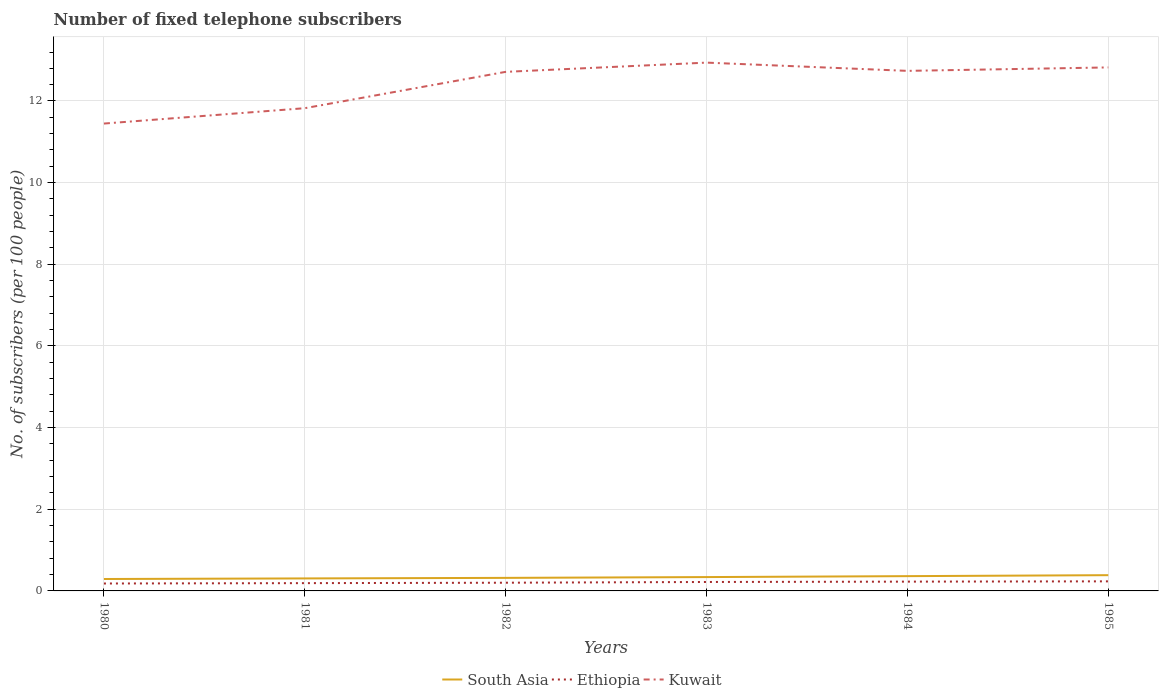Does the line corresponding to South Asia intersect with the line corresponding to Kuwait?
Keep it short and to the point. No. Across all years, what is the maximum number of fixed telephone subscribers in South Asia?
Your answer should be compact. 0.29. What is the total number of fixed telephone subscribers in Ethiopia in the graph?
Give a very brief answer. -0.01. What is the difference between the highest and the second highest number of fixed telephone subscribers in South Asia?
Make the answer very short. 0.09. What is the difference between the highest and the lowest number of fixed telephone subscribers in Kuwait?
Give a very brief answer. 4. How many lines are there?
Provide a succinct answer. 3. How many years are there in the graph?
Offer a terse response. 6. Are the values on the major ticks of Y-axis written in scientific E-notation?
Make the answer very short. No. Does the graph contain grids?
Ensure brevity in your answer.  Yes. Where does the legend appear in the graph?
Keep it short and to the point. Bottom center. How are the legend labels stacked?
Offer a very short reply. Horizontal. What is the title of the graph?
Your answer should be very brief. Number of fixed telephone subscribers. Does "Norway" appear as one of the legend labels in the graph?
Make the answer very short. No. What is the label or title of the X-axis?
Your response must be concise. Years. What is the label or title of the Y-axis?
Your answer should be very brief. No. of subscribers (per 100 people). What is the No. of subscribers (per 100 people) of South Asia in 1980?
Ensure brevity in your answer.  0.29. What is the No. of subscribers (per 100 people) of Ethiopia in 1980?
Offer a terse response. 0.18. What is the No. of subscribers (per 100 people) of Kuwait in 1980?
Offer a very short reply. 11.45. What is the No. of subscribers (per 100 people) of South Asia in 1981?
Give a very brief answer. 0.31. What is the No. of subscribers (per 100 people) in Ethiopia in 1981?
Ensure brevity in your answer.  0.19. What is the No. of subscribers (per 100 people) of Kuwait in 1981?
Provide a short and direct response. 11.82. What is the No. of subscribers (per 100 people) of South Asia in 1982?
Offer a terse response. 0.32. What is the No. of subscribers (per 100 people) of Ethiopia in 1982?
Your answer should be very brief. 0.2. What is the No. of subscribers (per 100 people) in Kuwait in 1982?
Offer a terse response. 12.71. What is the No. of subscribers (per 100 people) of South Asia in 1983?
Your answer should be compact. 0.34. What is the No. of subscribers (per 100 people) of Ethiopia in 1983?
Your response must be concise. 0.22. What is the No. of subscribers (per 100 people) in Kuwait in 1983?
Your answer should be compact. 12.94. What is the No. of subscribers (per 100 people) of South Asia in 1984?
Give a very brief answer. 0.36. What is the No. of subscribers (per 100 people) in Ethiopia in 1984?
Provide a succinct answer. 0.23. What is the No. of subscribers (per 100 people) in Kuwait in 1984?
Your answer should be compact. 12.74. What is the No. of subscribers (per 100 people) of South Asia in 1985?
Offer a very short reply. 0.39. What is the No. of subscribers (per 100 people) of Ethiopia in 1985?
Offer a very short reply. 0.23. What is the No. of subscribers (per 100 people) of Kuwait in 1985?
Make the answer very short. 12.82. Across all years, what is the maximum No. of subscribers (per 100 people) of South Asia?
Give a very brief answer. 0.39. Across all years, what is the maximum No. of subscribers (per 100 people) in Ethiopia?
Your response must be concise. 0.23. Across all years, what is the maximum No. of subscribers (per 100 people) of Kuwait?
Ensure brevity in your answer.  12.94. Across all years, what is the minimum No. of subscribers (per 100 people) in South Asia?
Your answer should be very brief. 0.29. Across all years, what is the minimum No. of subscribers (per 100 people) in Ethiopia?
Offer a terse response. 0.18. Across all years, what is the minimum No. of subscribers (per 100 people) of Kuwait?
Provide a short and direct response. 11.45. What is the total No. of subscribers (per 100 people) of South Asia in the graph?
Provide a succinct answer. 2. What is the total No. of subscribers (per 100 people) in Ethiopia in the graph?
Your response must be concise. 1.25. What is the total No. of subscribers (per 100 people) in Kuwait in the graph?
Your response must be concise. 74.49. What is the difference between the No. of subscribers (per 100 people) of South Asia in 1980 and that in 1981?
Provide a succinct answer. -0.01. What is the difference between the No. of subscribers (per 100 people) in Ethiopia in 1980 and that in 1981?
Offer a terse response. -0.01. What is the difference between the No. of subscribers (per 100 people) in Kuwait in 1980 and that in 1981?
Make the answer very short. -0.38. What is the difference between the No. of subscribers (per 100 people) of South Asia in 1980 and that in 1982?
Offer a terse response. -0.03. What is the difference between the No. of subscribers (per 100 people) in Ethiopia in 1980 and that in 1982?
Keep it short and to the point. -0.02. What is the difference between the No. of subscribers (per 100 people) in Kuwait in 1980 and that in 1982?
Ensure brevity in your answer.  -1.27. What is the difference between the No. of subscribers (per 100 people) in South Asia in 1980 and that in 1983?
Offer a terse response. -0.05. What is the difference between the No. of subscribers (per 100 people) in Ethiopia in 1980 and that in 1983?
Your response must be concise. -0.04. What is the difference between the No. of subscribers (per 100 people) in Kuwait in 1980 and that in 1983?
Your answer should be compact. -1.49. What is the difference between the No. of subscribers (per 100 people) of South Asia in 1980 and that in 1984?
Make the answer very short. -0.07. What is the difference between the No. of subscribers (per 100 people) in Ethiopia in 1980 and that in 1984?
Your response must be concise. -0.05. What is the difference between the No. of subscribers (per 100 people) of Kuwait in 1980 and that in 1984?
Ensure brevity in your answer.  -1.29. What is the difference between the No. of subscribers (per 100 people) in South Asia in 1980 and that in 1985?
Offer a very short reply. -0.09. What is the difference between the No. of subscribers (per 100 people) in Ethiopia in 1980 and that in 1985?
Offer a terse response. -0.05. What is the difference between the No. of subscribers (per 100 people) in Kuwait in 1980 and that in 1985?
Provide a succinct answer. -1.37. What is the difference between the No. of subscribers (per 100 people) of South Asia in 1981 and that in 1982?
Offer a terse response. -0.01. What is the difference between the No. of subscribers (per 100 people) in Ethiopia in 1981 and that in 1982?
Offer a very short reply. -0.01. What is the difference between the No. of subscribers (per 100 people) in Kuwait in 1981 and that in 1982?
Provide a succinct answer. -0.89. What is the difference between the No. of subscribers (per 100 people) in South Asia in 1981 and that in 1983?
Make the answer very short. -0.03. What is the difference between the No. of subscribers (per 100 people) of Ethiopia in 1981 and that in 1983?
Provide a succinct answer. -0.03. What is the difference between the No. of subscribers (per 100 people) of Kuwait in 1981 and that in 1983?
Make the answer very short. -1.12. What is the difference between the No. of subscribers (per 100 people) in South Asia in 1981 and that in 1984?
Your answer should be compact. -0.06. What is the difference between the No. of subscribers (per 100 people) of Ethiopia in 1981 and that in 1984?
Your response must be concise. -0.04. What is the difference between the No. of subscribers (per 100 people) of Kuwait in 1981 and that in 1984?
Your answer should be very brief. -0.91. What is the difference between the No. of subscribers (per 100 people) in South Asia in 1981 and that in 1985?
Provide a short and direct response. -0.08. What is the difference between the No. of subscribers (per 100 people) in Ethiopia in 1981 and that in 1985?
Make the answer very short. -0.04. What is the difference between the No. of subscribers (per 100 people) in Kuwait in 1981 and that in 1985?
Offer a very short reply. -1. What is the difference between the No. of subscribers (per 100 people) in South Asia in 1982 and that in 1983?
Your response must be concise. -0.02. What is the difference between the No. of subscribers (per 100 people) of Ethiopia in 1982 and that in 1983?
Your answer should be very brief. -0.02. What is the difference between the No. of subscribers (per 100 people) of Kuwait in 1982 and that in 1983?
Your answer should be very brief. -0.23. What is the difference between the No. of subscribers (per 100 people) of South Asia in 1982 and that in 1984?
Provide a short and direct response. -0.04. What is the difference between the No. of subscribers (per 100 people) of Ethiopia in 1982 and that in 1984?
Offer a very short reply. -0.03. What is the difference between the No. of subscribers (per 100 people) of Kuwait in 1982 and that in 1984?
Your response must be concise. -0.02. What is the difference between the No. of subscribers (per 100 people) of South Asia in 1982 and that in 1985?
Your response must be concise. -0.07. What is the difference between the No. of subscribers (per 100 people) in Ethiopia in 1982 and that in 1985?
Ensure brevity in your answer.  -0.03. What is the difference between the No. of subscribers (per 100 people) of Kuwait in 1982 and that in 1985?
Your answer should be compact. -0.11. What is the difference between the No. of subscribers (per 100 people) of South Asia in 1983 and that in 1984?
Give a very brief answer. -0.02. What is the difference between the No. of subscribers (per 100 people) in Ethiopia in 1983 and that in 1984?
Provide a short and direct response. -0.01. What is the difference between the No. of subscribers (per 100 people) of Kuwait in 1983 and that in 1984?
Offer a very short reply. 0.2. What is the difference between the No. of subscribers (per 100 people) of South Asia in 1983 and that in 1985?
Ensure brevity in your answer.  -0.05. What is the difference between the No. of subscribers (per 100 people) of Ethiopia in 1983 and that in 1985?
Your answer should be compact. -0.02. What is the difference between the No. of subscribers (per 100 people) in Kuwait in 1983 and that in 1985?
Provide a succinct answer. 0.12. What is the difference between the No. of subscribers (per 100 people) in South Asia in 1984 and that in 1985?
Your response must be concise. -0.02. What is the difference between the No. of subscribers (per 100 people) in Ethiopia in 1984 and that in 1985?
Make the answer very short. -0.01. What is the difference between the No. of subscribers (per 100 people) of Kuwait in 1984 and that in 1985?
Give a very brief answer. -0.08. What is the difference between the No. of subscribers (per 100 people) of South Asia in 1980 and the No. of subscribers (per 100 people) of Ethiopia in 1981?
Your response must be concise. 0.1. What is the difference between the No. of subscribers (per 100 people) in South Asia in 1980 and the No. of subscribers (per 100 people) in Kuwait in 1981?
Offer a very short reply. -11.53. What is the difference between the No. of subscribers (per 100 people) in Ethiopia in 1980 and the No. of subscribers (per 100 people) in Kuwait in 1981?
Offer a terse response. -11.64. What is the difference between the No. of subscribers (per 100 people) in South Asia in 1980 and the No. of subscribers (per 100 people) in Ethiopia in 1982?
Ensure brevity in your answer.  0.09. What is the difference between the No. of subscribers (per 100 people) of South Asia in 1980 and the No. of subscribers (per 100 people) of Kuwait in 1982?
Provide a short and direct response. -12.42. What is the difference between the No. of subscribers (per 100 people) of Ethiopia in 1980 and the No. of subscribers (per 100 people) of Kuwait in 1982?
Your answer should be very brief. -12.53. What is the difference between the No. of subscribers (per 100 people) in South Asia in 1980 and the No. of subscribers (per 100 people) in Ethiopia in 1983?
Your answer should be very brief. 0.07. What is the difference between the No. of subscribers (per 100 people) in South Asia in 1980 and the No. of subscribers (per 100 people) in Kuwait in 1983?
Your answer should be compact. -12.65. What is the difference between the No. of subscribers (per 100 people) in Ethiopia in 1980 and the No. of subscribers (per 100 people) in Kuwait in 1983?
Your response must be concise. -12.76. What is the difference between the No. of subscribers (per 100 people) in South Asia in 1980 and the No. of subscribers (per 100 people) in Ethiopia in 1984?
Provide a succinct answer. 0.06. What is the difference between the No. of subscribers (per 100 people) in South Asia in 1980 and the No. of subscribers (per 100 people) in Kuwait in 1984?
Provide a short and direct response. -12.45. What is the difference between the No. of subscribers (per 100 people) in Ethiopia in 1980 and the No. of subscribers (per 100 people) in Kuwait in 1984?
Provide a succinct answer. -12.56. What is the difference between the No. of subscribers (per 100 people) of South Asia in 1980 and the No. of subscribers (per 100 people) of Ethiopia in 1985?
Provide a succinct answer. 0.06. What is the difference between the No. of subscribers (per 100 people) in South Asia in 1980 and the No. of subscribers (per 100 people) in Kuwait in 1985?
Your answer should be very brief. -12.53. What is the difference between the No. of subscribers (per 100 people) in Ethiopia in 1980 and the No. of subscribers (per 100 people) in Kuwait in 1985?
Provide a short and direct response. -12.64. What is the difference between the No. of subscribers (per 100 people) of South Asia in 1981 and the No. of subscribers (per 100 people) of Ethiopia in 1982?
Give a very brief answer. 0.11. What is the difference between the No. of subscribers (per 100 people) in South Asia in 1981 and the No. of subscribers (per 100 people) in Kuwait in 1982?
Offer a terse response. -12.41. What is the difference between the No. of subscribers (per 100 people) of Ethiopia in 1981 and the No. of subscribers (per 100 people) of Kuwait in 1982?
Provide a succinct answer. -12.52. What is the difference between the No. of subscribers (per 100 people) in South Asia in 1981 and the No. of subscribers (per 100 people) in Ethiopia in 1983?
Your answer should be very brief. 0.09. What is the difference between the No. of subscribers (per 100 people) in South Asia in 1981 and the No. of subscribers (per 100 people) in Kuwait in 1983?
Your answer should be compact. -12.63. What is the difference between the No. of subscribers (per 100 people) in Ethiopia in 1981 and the No. of subscribers (per 100 people) in Kuwait in 1983?
Your response must be concise. -12.75. What is the difference between the No. of subscribers (per 100 people) of South Asia in 1981 and the No. of subscribers (per 100 people) of Ethiopia in 1984?
Your response must be concise. 0.08. What is the difference between the No. of subscribers (per 100 people) of South Asia in 1981 and the No. of subscribers (per 100 people) of Kuwait in 1984?
Ensure brevity in your answer.  -12.43. What is the difference between the No. of subscribers (per 100 people) in Ethiopia in 1981 and the No. of subscribers (per 100 people) in Kuwait in 1984?
Your answer should be compact. -12.55. What is the difference between the No. of subscribers (per 100 people) in South Asia in 1981 and the No. of subscribers (per 100 people) in Ethiopia in 1985?
Provide a succinct answer. 0.07. What is the difference between the No. of subscribers (per 100 people) of South Asia in 1981 and the No. of subscribers (per 100 people) of Kuwait in 1985?
Your response must be concise. -12.52. What is the difference between the No. of subscribers (per 100 people) in Ethiopia in 1981 and the No. of subscribers (per 100 people) in Kuwait in 1985?
Ensure brevity in your answer.  -12.63. What is the difference between the No. of subscribers (per 100 people) in South Asia in 1982 and the No. of subscribers (per 100 people) in Ethiopia in 1983?
Give a very brief answer. 0.1. What is the difference between the No. of subscribers (per 100 people) in South Asia in 1982 and the No. of subscribers (per 100 people) in Kuwait in 1983?
Keep it short and to the point. -12.62. What is the difference between the No. of subscribers (per 100 people) in Ethiopia in 1982 and the No. of subscribers (per 100 people) in Kuwait in 1983?
Offer a terse response. -12.74. What is the difference between the No. of subscribers (per 100 people) of South Asia in 1982 and the No. of subscribers (per 100 people) of Ethiopia in 1984?
Offer a very short reply. 0.09. What is the difference between the No. of subscribers (per 100 people) of South Asia in 1982 and the No. of subscribers (per 100 people) of Kuwait in 1984?
Provide a succinct answer. -12.42. What is the difference between the No. of subscribers (per 100 people) of Ethiopia in 1982 and the No. of subscribers (per 100 people) of Kuwait in 1984?
Provide a succinct answer. -12.54. What is the difference between the No. of subscribers (per 100 people) of South Asia in 1982 and the No. of subscribers (per 100 people) of Ethiopia in 1985?
Provide a succinct answer. 0.09. What is the difference between the No. of subscribers (per 100 people) of South Asia in 1982 and the No. of subscribers (per 100 people) of Kuwait in 1985?
Provide a short and direct response. -12.5. What is the difference between the No. of subscribers (per 100 people) of Ethiopia in 1982 and the No. of subscribers (per 100 people) of Kuwait in 1985?
Give a very brief answer. -12.62. What is the difference between the No. of subscribers (per 100 people) in South Asia in 1983 and the No. of subscribers (per 100 people) in Ethiopia in 1984?
Offer a terse response. 0.11. What is the difference between the No. of subscribers (per 100 people) in South Asia in 1983 and the No. of subscribers (per 100 people) in Kuwait in 1984?
Your answer should be very brief. -12.4. What is the difference between the No. of subscribers (per 100 people) in Ethiopia in 1983 and the No. of subscribers (per 100 people) in Kuwait in 1984?
Keep it short and to the point. -12.52. What is the difference between the No. of subscribers (per 100 people) in South Asia in 1983 and the No. of subscribers (per 100 people) in Ethiopia in 1985?
Your answer should be compact. 0.1. What is the difference between the No. of subscribers (per 100 people) of South Asia in 1983 and the No. of subscribers (per 100 people) of Kuwait in 1985?
Give a very brief answer. -12.48. What is the difference between the No. of subscribers (per 100 people) of Ethiopia in 1983 and the No. of subscribers (per 100 people) of Kuwait in 1985?
Your answer should be very brief. -12.6. What is the difference between the No. of subscribers (per 100 people) of South Asia in 1984 and the No. of subscribers (per 100 people) of Ethiopia in 1985?
Your answer should be very brief. 0.13. What is the difference between the No. of subscribers (per 100 people) in South Asia in 1984 and the No. of subscribers (per 100 people) in Kuwait in 1985?
Your response must be concise. -12.46. What is the difference between the No. of subscribers (per 100 people) in Ethiopia in 1984 and the No. of subscribers (per 100 people) in Kuwait in 1985?
Your response must be concise. -12.59. What is the average No. of subscribers (per 100 people) in South Asia per year?
Your answer should be very brief. 0.33. What is the average No. of subscribers (per 100 people) in Ethiopia per year?
Your answer should be compact. 0.21. What is the average No. of subscribers (per 100 people) in Kuwait per year?
Offer a very short reply. 12.41. In the year 1980, what is the difference between the No. of subscribers (per 100 people) of South Asia and No. of subscribers (per 100 people) of Ethiopia?
Keep it short and to the point. 0.11. In the year 1980, what is the difference between the No. of subscribers (per 100 people) in South Asia and No. of subscribers (per 100 people) in Kuwait?
Give a very brief answer. -11.16. In the year 1980, what is the difference between the No. of subscribers (per 100 people) in Ethiopia and No. of subscribers (per 100 people) in Kuwait?
Your response must be concise. -11.27. In the year 1981, what is the difference between the No. of subscribers (per 100 people) of South Asia and No. of subscribers (per 100 people) of Ethiopia?
Keep it short and to the point. 0.12. In the year 1981, what is the difference between the No. of subscribers (per 100 people) in South Asia and No. of subscribers (per 100 people) in Kuwait?
Give a very brief answer. -11.52. In the year 1981, what is the difference between the No. of subscribers (per 100 people) of Ethiopia and No. of subscribers (per 100 people) of Kuwait?
Give a very brief answer. -11.63. In the year 1982, what is the difference between the No. of subscribers (per 100 people) of South Asia and No. of subscribers (per 100 people) of Ethiopia?
Ensure brevity in your answer.  0.12. In the year 1982, what is the difference between the No. of subscribers (per 100 people) in South Asia and No. of subscribers (per 100 people) in Kuwait?
Give a very brief answer. -12.39. In the year 1982, what is the difference between the No. of subscribers (per 100 people) in Ethiopia and No. of subscribers (per 100 people) in Kuwait?
Give a very brief answer. -12.51. In the year 1983, what is the difference between the No. of subscribers (per 100 people) of South Asia and No. of subscribers (per 100 people) of Ethiopia?
Make the answer very short. 0.12. In the year 1983, what is the difference between the No. of subscribers (per 100 people) in South Asia and No. of subscribers (per 100 people) in Kuwait?
Your answer should be compact. -12.6. In the year 1983, what is the difference between the No. of subscribers (per 100 people) in Ethiopia and No. of subscribers (per 100 people) in Kuwait?
Your answer should be very brief. -12.72. In the year 1984, what is the difference between the No. of subscribers (per 100 people) in South Asia and No. of subscribers (per 100 people) in Ethiopia?
Your answer should be very brief. 0.13. In the year 1984, what is the difference between the No. of subscribers (per 100 people) in South Asia and No. of subscribers (per 100 people) in Kuwait?
Your answer should be very brief. -12.38. In the year 1984, what is the difference between the No. of subscribers (per 100 people) of Ethiopia and No. of subscribers (per 100 people) of Kuwait?
Your answer should be compact. -12.51. In the year 1985, what is the difference between the No. of subscribers (per 100 people) of South Asia and No. of subscribers (per 100 people) of Ethiopia?
Offer a very short reply. 0.15. In the year 1985, what is the difference between the No. of subscribers (per 100 people) of South Asia and No. of subscribers (per 100 people) of Kuwait?
Your answer should be very brief. -12.44. In the year 1985, what is the difference between the No. of subscribers (per 100 people) of Ethiopia and No. of subscribers (per 100 people) of Kuwait?
Make the answer very short. -12.59. What is the ratio of the No. of subscribers (per 100 people) of South Asia in 1980 to that in 1981?
Provide a short and direct response. 0.95. What is the ratio of the No. of subscribers (per 100 people) in Ethiopia in 1980 to that in 1981?
Ensure brevity in your answer.  0.95. What is the ratio of the No. of subscribers (per 100 people) in Kuwait in 1980 to that in 1981?
Your answer should be compact. 0.97. What is the ratio of the No. of subscribers (per 100 people) in South Asia in 1980 to that in 1982?
Make the answer very short. 0.91. What is the ratio of the No. of subscribers (per 100 people) in Ethiopia in 1980 to that in 1982?
Your answer should be very brief. 0.9. What is the ratio of the No. of subscribers (per 100 people) in Kuwait in 1980 to that in 1982?
Provide a short and direct response. 0.9. What is the ratio of the No. of subscribers (per 100 people) in South Asia in 1980 to that in 1983?
Provide a succinct answer. 0.86. What is the ratio of the No. of subscribers (per 100 people) of Ethiopia in 1980 to that in 1983?
Your response must be concise. 0.83. What is the ratio of the No. of subscribers (per 100 people) in Kuwait in 1980 to that in 1983?
Your response must be concise. 0.88. What is the ratio of the No. of subscribers (per 100 people) of South Asia in 1980 to that in 1984?
Provide a succinct answer. 0.81. What is the ratio of the No. of subscribers (per 100 people) in Ethiopia in 1980 to that in 1984?
Offer a terse response. 0.8. What is the ratio of the No. of subscribers (per 100 people) in Kuwait in 1980 to that in 1984?
Make the answer very short. 0.9. What is the ratio of the No. of subscribers (per 100 people) in South Asia in 1980 to that in 1985?
Your response must be concise. 0.76. What is the ratio of the No. of subscribers (per 100 people) of Ethiopia in 1980 to that in 1985?
Ensure brevity in your answer.  0.78. What is the ratio of the No. of subscribers (per 100 people) in Kuwait in 1980 to that in 1985?
Give a very brief answer. 0.89. What is the ratio of the No. of subscribers (per 100 people) of South Asia in 1981 to that in 1982?
Make the answer very short. 0.96. What is the ratio of the No. of subscribers (per 100 people) in Ethiopia in 1981 to that in 1982?
Make the answer very short. 0.95. What is the ratio of the No. of subscribers (per 100 people) in South Asia in 1981 to that in 1983?
Ensure brevity in your answer.  0.9. What is the ratio of the No. of subscribers (per 100 people) of Ethiopia in 1981 to that in 1983?
Offer a very short reply. 0.87. What is the ratio of the No. of subscribers (per 100 people) of Kuwait in 1981 to that in 1983?
Ensure brevity in your answer.  0.91. What is the ratio of the No. of subscribers (per 100 people) in South Asia in 1981 to that in 1984?
Your answer should be very brief. 0.85. What is the ratio of the No. of subscribers (per 100 people) of Ethiopia in 1981 to that in 1984?
Give a very brief answer. 0.84. What is the ratio of the No. of subscribers (per 100 people) in Kuwait in 1981 to that in 1984?
Your response must be concise. 0.93. What is the ratio of the No. of subscribers (per 100 people) in South Asia in 1981 to that in 1985?
Your response must be concise. 0.79. What is the ratio of the No. of subscribers (per 100 people) in Ethiopia in 1981 to that in 1985?
Provide a short and direct response. 0.81. What is the ratio of the No. of subscribers (per 100 people) of Kuwait in 1981 to that in 1985?
Make the answer very short. 0.92. What is the ratio of the No. of subscribers (per 100 people) of South Asia in 1982 to that in 1983?
Make the answer very short. 0.94. What is the ratio of the No. of subscribers (per 100 people) in Ethiopia in 1982 to that in 1983?
Offer a terse response. 0.92. What is the ratio of the No. of subscribers (per 100 people) of Kuwait in 1982 to that in 1983?
Provide a succinct answer. 0.98. What is the ratio of the No. of subscribers (per 100 people) in South Asia in 1982 to that in 1984?
Provide a succinct answer. 0.88. What is the ratio of the No. of subscribers (per 100 people) of Ethiopia in 1982 to that in 1984?
Ensure brevity in your answer.  0.88. What is the ratio of the No. of subscribers (per 100 people) of South Asia in 1982 to that in 1985?
Keep it short and to the point. 0.83. What is the ratio of the No. of subscribers (per 100 people) of Ethiopia in 1982 to that in 1985?
Ensure brevity in your answer.  0.86. What is the ratio of the No. of subscribers (per 100 people) in Kuwait in 1982 to that in 1985?
Your response must be concise. 0.99. What is the ratio of the No. of subscribers (per 100 people) of South Asia in 1983 to that in 1984?
Offer a terse response. 0.94. What is the ratio of the No. of subscribers (per 100 people) of Ethiopia in 1983 to that in 1984?
Provide a succinct answer. 0.96. What is the ratio of the No. of subscribers (per 100 people) in Kuwait in 1983 to that in 1984?
Give a very brief answer. 1.02. What is the ratio of the No. of subscribers (per 100 people) of South Asia in 1983 to that in 1985?
Your response must be concise. 0.88. What is the ratio of the No. of subscribers (per 100 people) of Ethiopia in 1983 to that in 1985?
Ensure brevity in your answer.  0.93. What is the ratio of the No. of subscribers (per 100 people) of Kuwait in 1983 to that in 1985?
Provide a succinct answer. 1.01. What is the ratio of the No. of subscribers (per 100 people) in South Asia in 1984 to that in 1985?
Provide a short and direct response. 0.94. What is the ratio of the No. of subscribers (per 100 people) in Ethiopia in 1984 to that in 1985?
Ensure brevity in your answer.  0.97. What is the difference between the highest and the second highest No. of subscribers (per 100 people) of South Asia?
Give a very brief answer. 0.02. What is the difference between the highest and the second highest No. of subscribers (per 100 people) of Ethiopia?
Give a very brief answer. 0.01. What is the difference between the highest and the second highest No. of subscribers (per 100 people) in Kuwait?
Keep it short and to the point. 0.12. What is the difference between the highest and the lowest No. of subscribers (per 100 people) in South Asia?
Offer a terse response. 0.09. What is the difference between the highest and the lowest No. of subscribers (per 100 people) in Ethiopia?
Your answer should be compact. 0.05. What is the difference between the highest and the lowest No. of subscribers (per 100 people) in Kuwait?
Provide a short and direct response. 1.49. 